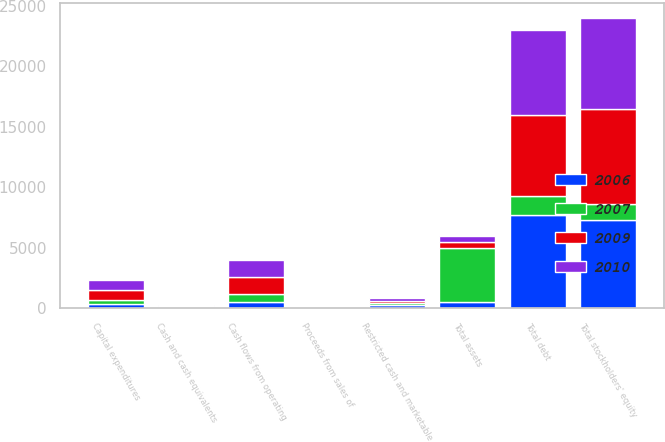<chart> <loc_0><loc_0><loc_500><loc_500><stacked_bar_chart><ecel><fcel>Cash flows from operating<fcel>Capital expenditures<fcel>Proceeds from sales of<fcel>Cash and cash equivalents<fcel>Restricted cash and marketable<fcel>Total assets<fcel>Total debt<fcel>Total stockholders' equity<nl><fcel>2009<fcel>1433.7<fcel>794.7<fcel>37.4<fcel>88.3<fcel>172.8<fcel>512.2<fcel>6743.6<fcel>7848.9<nl><fcel>2010<fcel>1396.5<fcel>826.3<fcel>31.8<fcel>48<fcel>240.5<fcel>512.2<fcel>6962.6<fcel>7567.1<nl><fcel>2006<fcel>512.2<fcel>386.9<fcel>8.2<fcel>68.7<fcel>281.9<fcel>512.2<fcel>7702.5<fcel>7282.5<nl><fcel>2007<fcel>661.3<fcel>292.5<fcel>6.1<fcel>21.8<fcel>165<fcel>4467.8<fcel>1567.8<fcel>1303.8<nl></chart> 